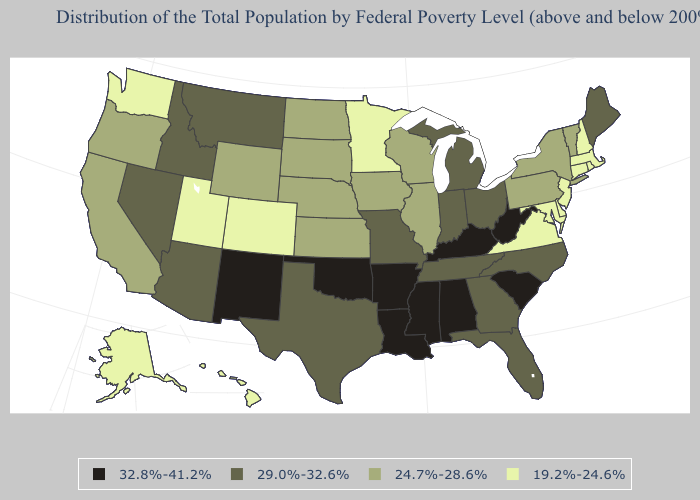What is the lowest value in states that border Minnesota?
Be succinct. 24.7%-28.6%. Name the states that have a value in the range 29.0%-32.6%?
Write a very short answer. Arizona, Florida, Georgia, Idaho, Indiana, Maine, Michigan, Missouri, Montana, Nevada, North Carolina, Ohio, Tennessee, Texas. What is the value of Alabama?
Keep it brief. 32.8%-41.2%. Name the states that have a value in the range 19.2%-24.6%?
Write a very short answer. Alaska, Colorado, Connecticut, Delaware, Hawaii, Maryland, Massachusetts, Minnesota, New Hampshire, New Jersey, Rhode Island, Utah, Virginia, Washington. What is the value of South Dakota?
Give a very brief answer. 24.7%-28.6%. Does Maine have the lowest value in the Northeast?
Short answer required. No. Name the states that have a value in the range 29.0%-32.6%?
Short answer required. Arizona, Florida, Georgia, Idaho, Indiana, Maine, Michigan, Missouri, Montana, Nevada, North Carolina, Ohio, Tennessee, Texas. What is the value of Arizona?
Give a very brief answer. 29.0%-32.6%. Name the states that have a value in the range 29.0%-32.6%?
Answer briefly. Arizona, Florida, Georgia, Idaho, Indiana, Maine, Michigan, Missouri, Montana, Nevada, North Carolina, Ohio, Tennessee, Texas. What is the lowest value in the West?
Write a very short answer. 19.2%-24.6%. What is the lowest value in the USA?
Keep it brief. 19.2%-24.6%. Name the states that have a value in the range 24.7%-28.6%?
Write a very short answer. California, Illinois, Iowa, Kansas, Nebraska, New York, North Dakota, Oregon, Pennsylvania, South Dakota, Vermont, Wisconsin, Wyoming. What is the value of Colorado?
Give a very brief answer. 19.2%-24.6%. Does Minnesota have the highest value in the MidWest?
Concise answer only. No. Name the states that have a value in the range 29.0%-32.6%?
Write a very short answer. Arizona, Florida, Georgia, Idaho, Indiana, Maine, Michigan, Missouri, Montana, Nevada, North Carolina, Ohio, Tennessee, Texas. 